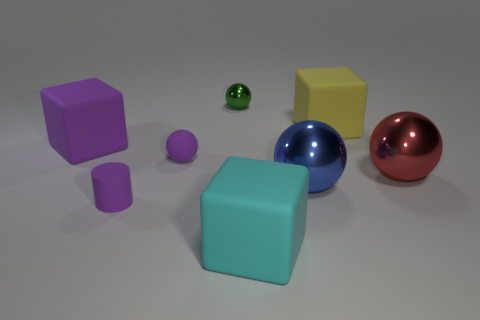Can you describe the colors and shapes in the image? The image features a variety of geometric shapes in different colors. There's a large cyan cube, a large purple cube, a smaller purple cylinder, a large yellow cube, a blue shiny sphere, and a red shiny sphere. Additionally, there's a small green glossy sphere and a very small purple sphere. 